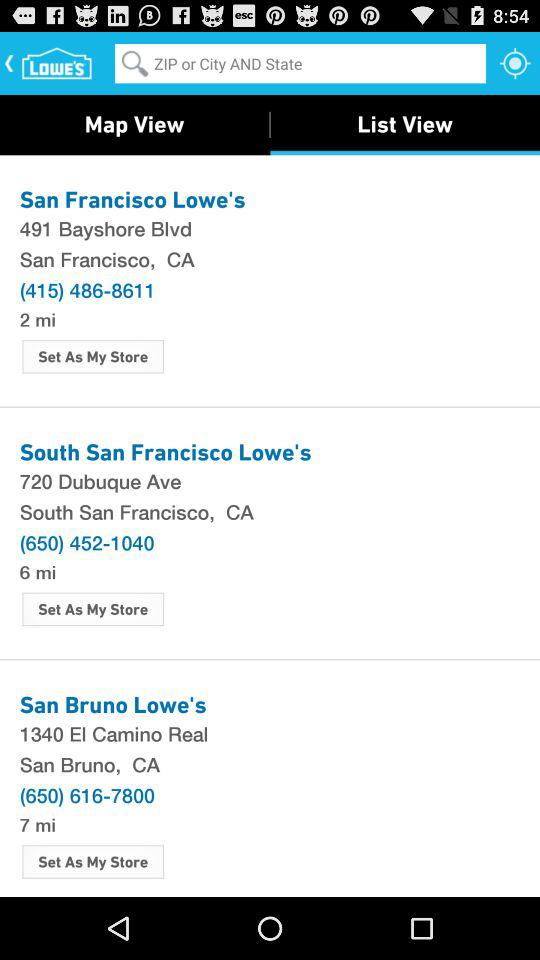Which tab am I on? You are on "List View" tab. 